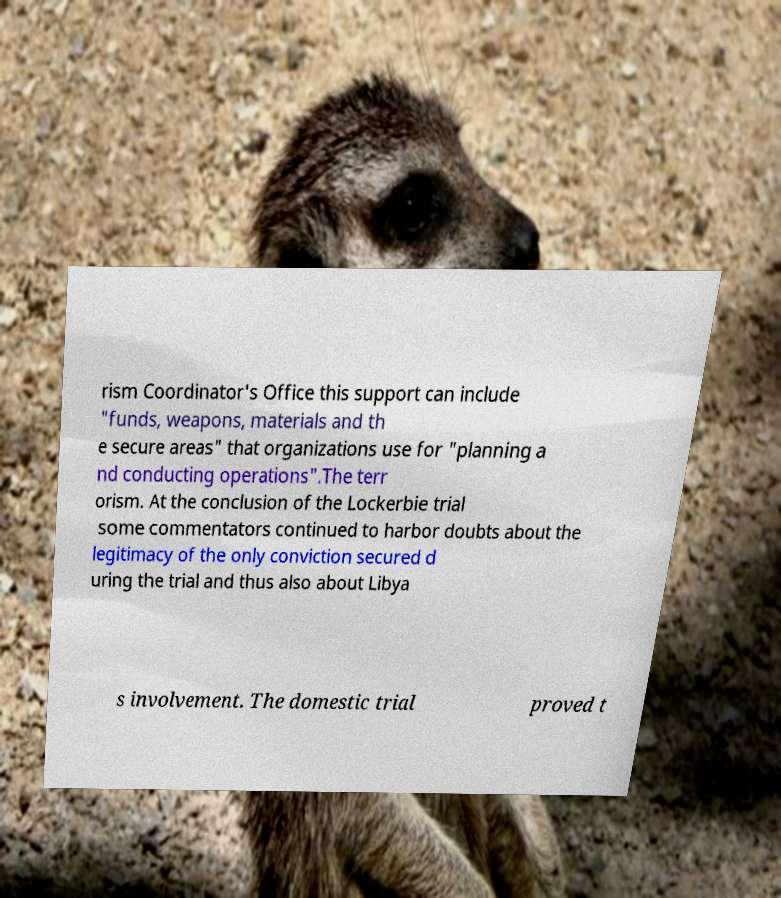Please identify and transcribe the text found in this image. rism Coordinator's Office this support can include "funds, weapons, materials and th e secure areas" that organizations use for "planning a nd conducting operations".The terr orism. At the conclusion of the Lockerbie trial some commentators continued to harbor doubts about the legitimacy of the only conviction secured d uring the trial and thus also about Libya s involvement. The domestic trial proved t 